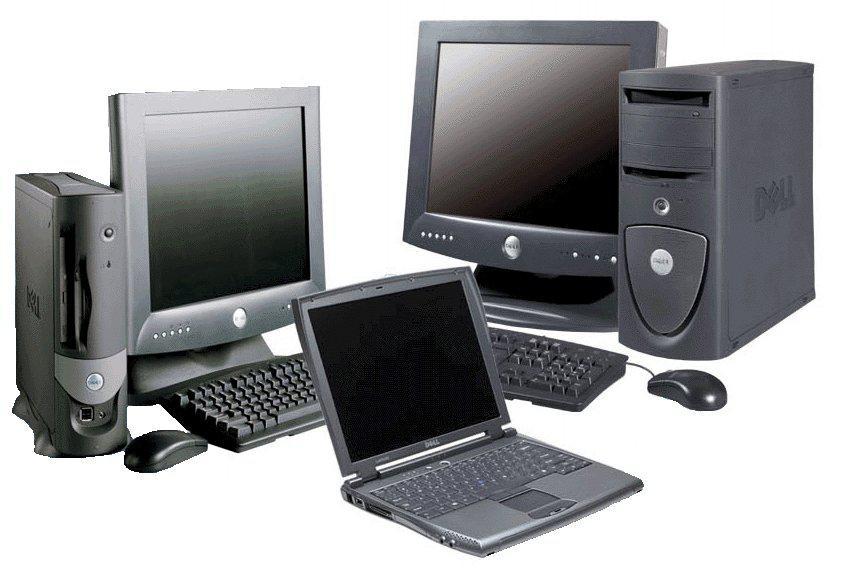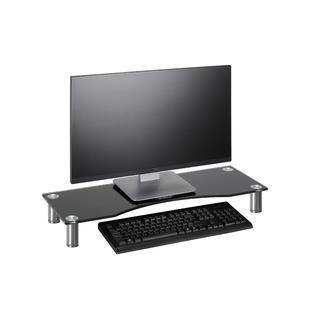The first image is the image on the left, the second image is the image on the right. Analyze the images presented: Is the assertion "Three computers are displayed in the image on the right." valid? Answer yes or no. No. The first image is the image on the left, the second image is the image on the right. Examine the images to the left and right. Is the description "One image shows a brown desk with three computer screens visible on top of it." accurate? Answer yes or no. No. 